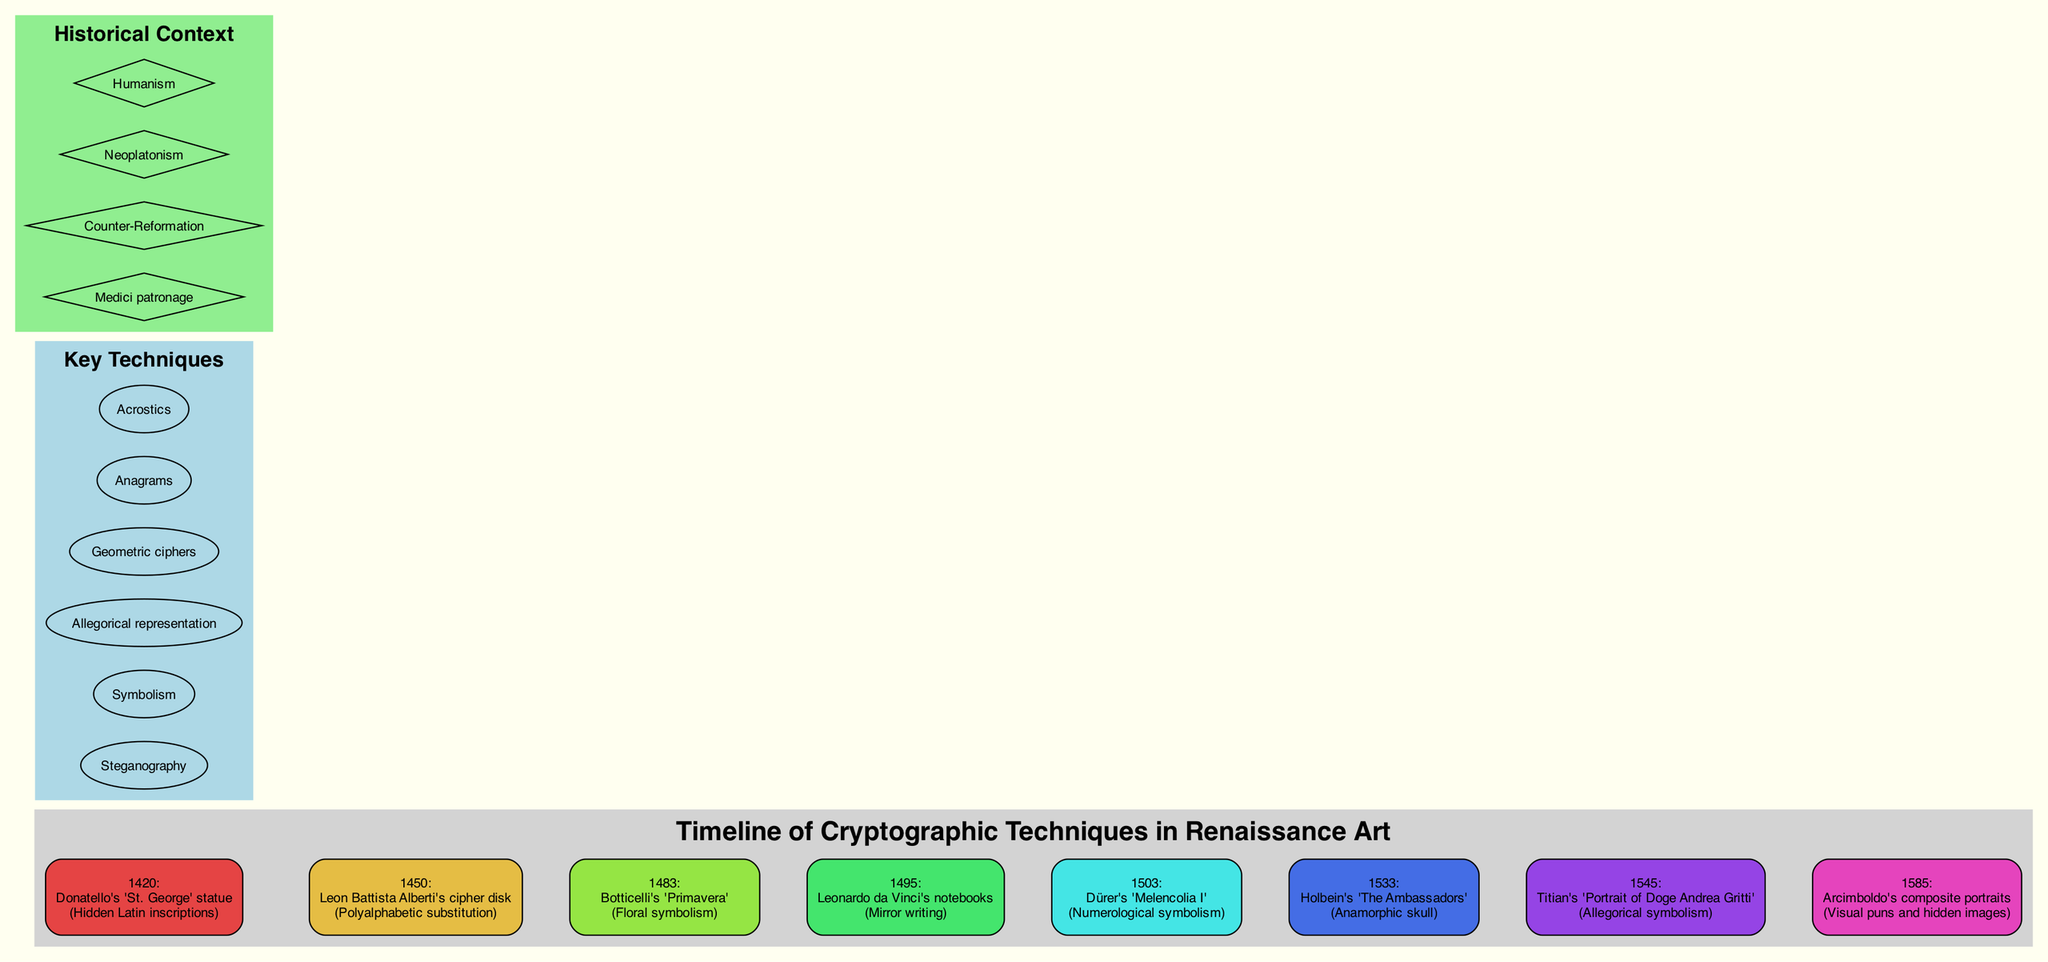What event is associated with the year 1533? The diagram shows a timeline, and we can locate the year 1533. In that section, we see "Holbein's 'The Ambassadors'" listed as the event for that year.
Answer: Holbein's 'The Ambassadors' Which technique is used in Botticelli's 'Primavera'? By examining the timeline, we find that Botticelli's 'Primavera' corresponds to the year 1483. It specifies "Floral symbolism" as the technique used in that artwork.
Answer: Floral symbolism How many key techniques are listed in the diagram? The section titled "Key Techniques" consists of a series of nodes. Counting these nodes, we find there are six key techniques listed.
Answer: 6 What is the historical context associated with Dürer’s 'Melencolia I'? Looking at the timeline, we note that Dürer's 'Melencolia I' is listed under the year 1503. However, the historical context nodes are separate and do not connect directly to this timeline. Thus, we can't specify a context from the timeline for this event.
Answer: None Identify the technique used in Leonardo da Vinci's notebooks. The timeline clearly identifies that under the year 1495 marks Leonardo da Vinci's notebooks, where "Mirror writing" is noted as the technique.
Answer: Mirror writing Which artwork used an anamorphic skull as a technique? In reviewing the timeline, under the year 1533, we find that "Holbein's 'The Ambassadors'" is identified as utilizing the technique of an anamorphic skull.
Answer: Holbein's 'The Ambassadors' In what year did the use of visual puns and hidden images appear in Renaissance art? Referencing the timeline, we find that the year 1585 is associated with Arcimboldo's composite portraits, which explicitly state the technique of visual puns and hidden images.
Answer: 1585 What is the significance of the Medici patronage in relation to the timeline? The timeline includes a separate section for historical contexts but does not detail how the Medici patronage specifically relates to individual events. Therefore, it indicates that while significant, specific connections to events are not clearly denoted.
Answer: None 